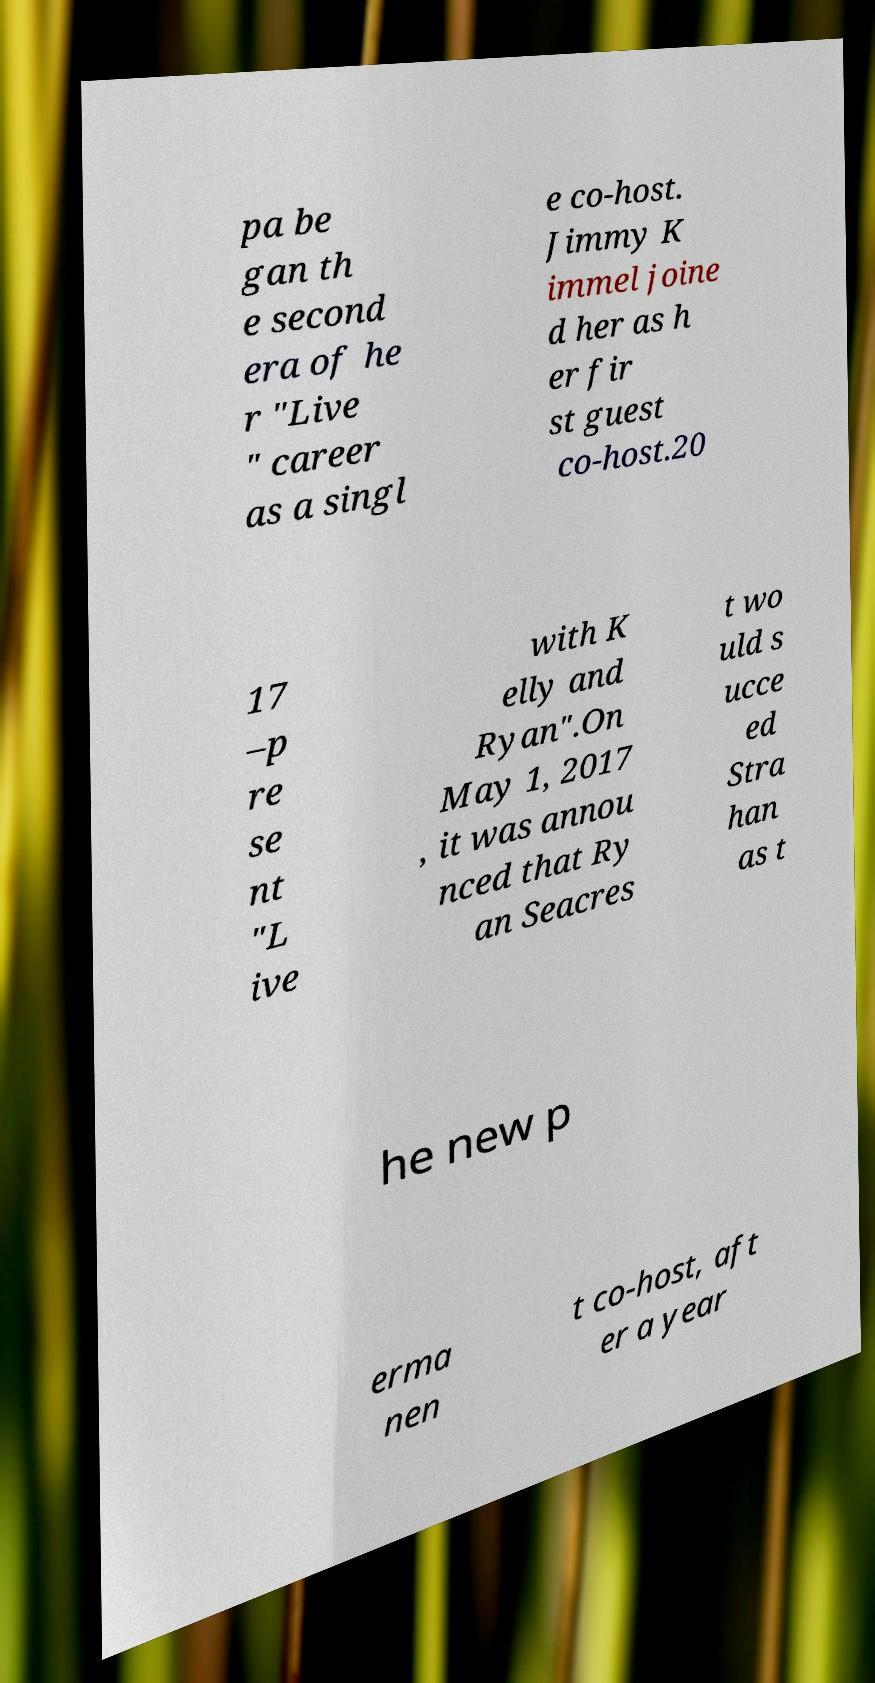Could you extract and type out the text from this image? pa be gan th e second era of he r "Live " career as a singl e co-host. Jimmy K immel joine d her as h er fir st guest co-host.20 17 –p re se nt "L ive with K elly and Ryan".On May 1, 2017 , it was annou nced that Ry an Seacres t wo uld s ucce ed Stra han as t he new p erma nen t co-host, aft er a year 